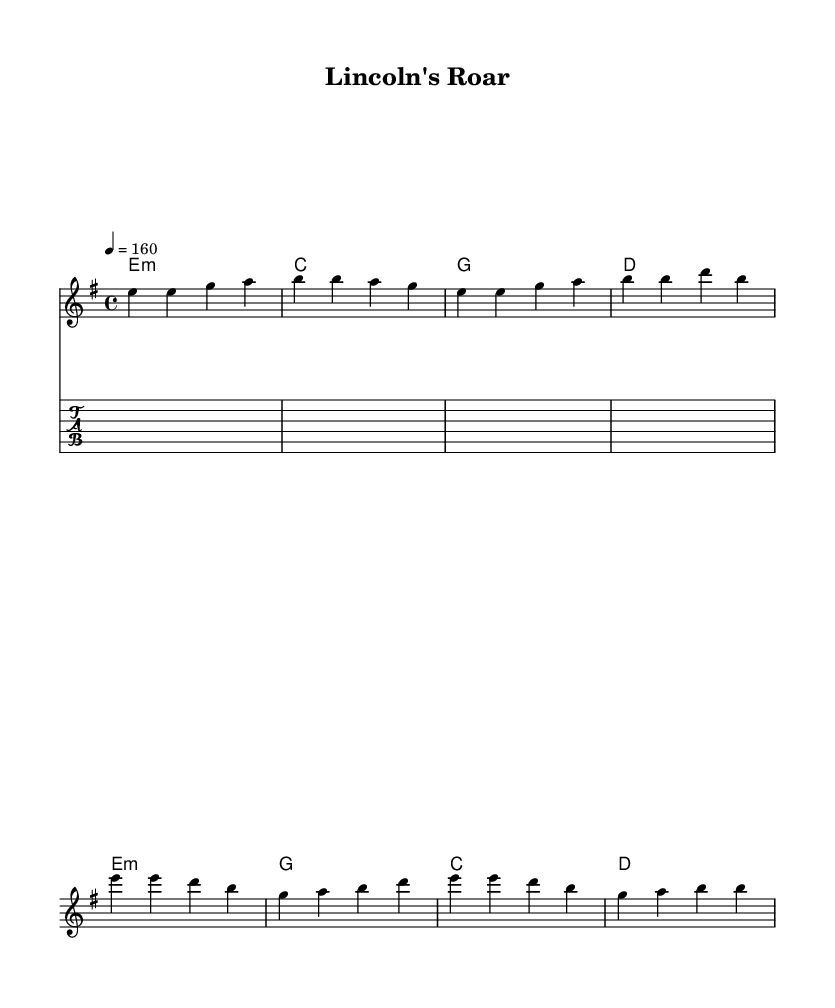What is the key signature of this music? The key signature is E minor, which has one sharp (F#). This can be determined by looking at the key signature indicated at the beginning of the score.
Answer: E minor What is the time signature of this music? The time signature is 4/4. This is indicated at the beginning of the score, where it shows how many beats are in each measure and the type of note that gets one beat.
Answer: 4/4 What is the tempo marking of this music? The tempo marking is 160 beats per minute, indicated by the marking "4 = 160" in the score. This tells us the speed at which the piece should be played.
Answer: 160 How many measures are in the verse section? There are four measures in the verse section. Counting the measures in the melody part that corresponds to the verse lyrics, we find four distinct groupings.
Answer: 4 What is the chord progression for the chorus? The chord progression for the chorus is E minor, G, C, D. This can be determined by examining the chord names written in the harmony section that align with the melody in the chorus.
Answer: E minor, G, C, D What is the musical style of this piece? The musical style is Heavy Metal, as indicated by the overall structure, tempo, and use of power chords typical in metal music. Additionally, the theme reflects triumph, which resonates with many heavy metal anthems.
Answer: Heavy Metal How is the guitar riff structured? The guitar riff consists of repeated eighth notes, specifically a pattern played four times that features D and A notes. This repetition and rhythmic drive are characteristic of the heavy metal genre.
Answer: D, A 